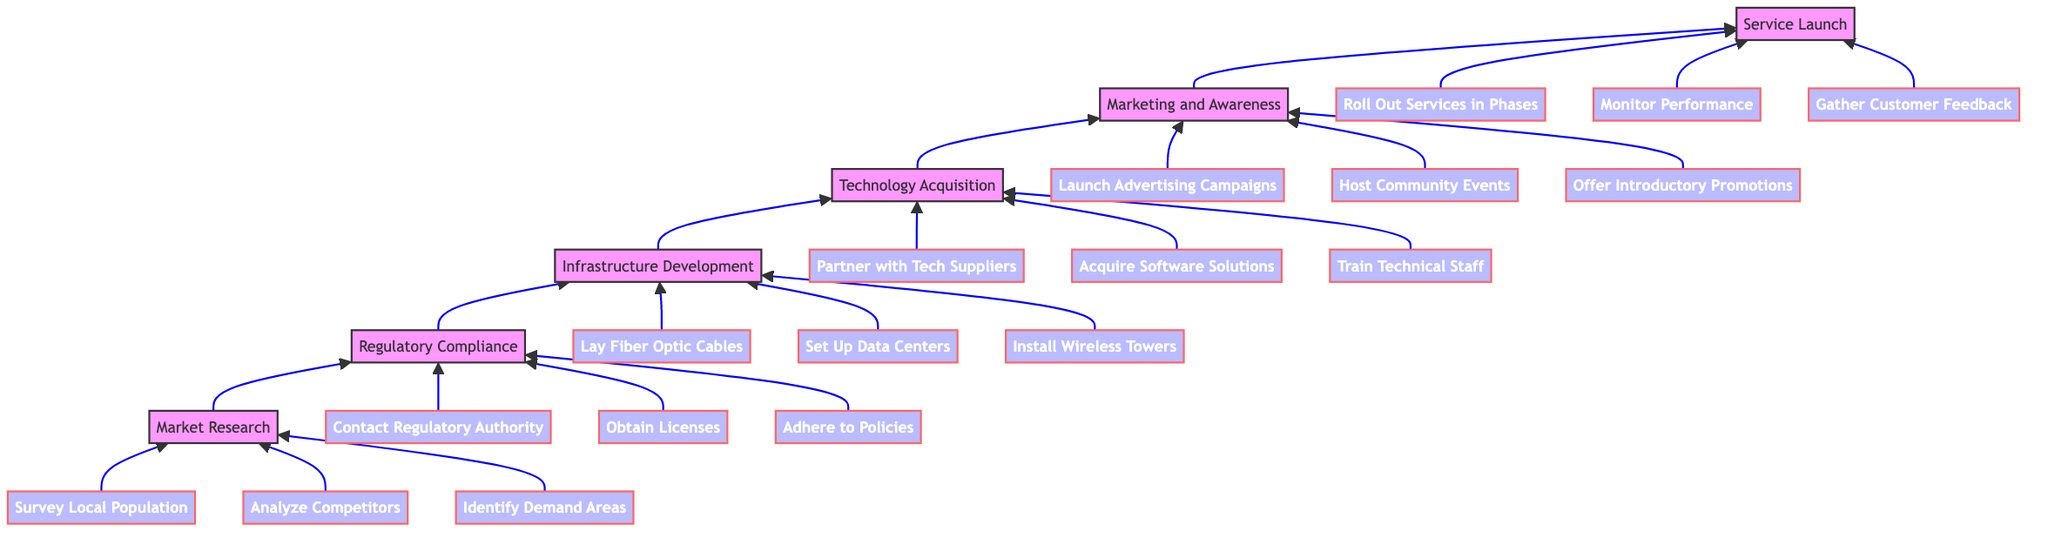What is the first step in the rollout plan? The first step in the rollout plan, as represented at the bottom of the diagram, is "Market Research." This is the starting point from which all subsequent steps flow upward.
Answer: Market Research How many primary steps are in the rollout plan? Counting the main elements in the diagram from the bottom to the top, there are six primary steps: Market Research, Regulatory Compliance, Infrastructure Development, Technology Acquisition, Marketing and Awareness, and Service Launch.
Answer: Six What is the last step in the rollout plan? The last step in the rollout plan, which is positioned at the top of the diagram, is "Service Launch." This indicates the culmination of all preceding steps leading to the initiation of ISP services.
Answer: Service Launch Which task follows "Infrastructure Development"? After "Infrastructure Development," the next task in the upward flow is "Technology Acquisition." This indicates the progression from building the infrastructure to acquiring the necessary technology for operation.
Answer: Technology Acquisition How many subtasks are associated with "Marketing and Awareness"? The subtask section beneath "Marketing and Awareness" includes three specific tasks: "Launch Advertising Campaigns," "Host Community Events," and "Offer Introductory Promotions." Therefore, the count of subtasks is three.
Answer: Three What must be completed before "Service Launch"? "Marketing and Awareness" must be completed before "Service Launch." The direction of the flow indicates that marketing efforts need to precede the official launch of services.
Answer: Marketing and Awareness Which regulatory task involves engaging an authority? The task under "Regulatory Compliance" that involves engaging an authority is "Contact Regulatory Authority." This indicates the initial step in ensuring legal compliance for the ISP.
Answer: Contact Regulatory Authority What is the purpose of conducting surveys in the process? The purpose of conducting surveys, which is a subtask of "Market Research," is to gauge interest and preferred services from the local population. This helps in tailoring the ISP offerings to meet local needs.
Answer: Gauge interest Which step directly leads to the installation of wireless towers? The installation of wireless towers is a subtask of "Infrastructure Development." Therefore, the step that directly leads to this action is "Infrastructure Development."
Answer: Infrastructure Development What type of events should be hosted for community engagement? "Host Community Events" is the type of event listed under "Marketing and Awareness," aimed at demonstrating new services and soliciting feedback from the community.
Answer: Host Community Events 